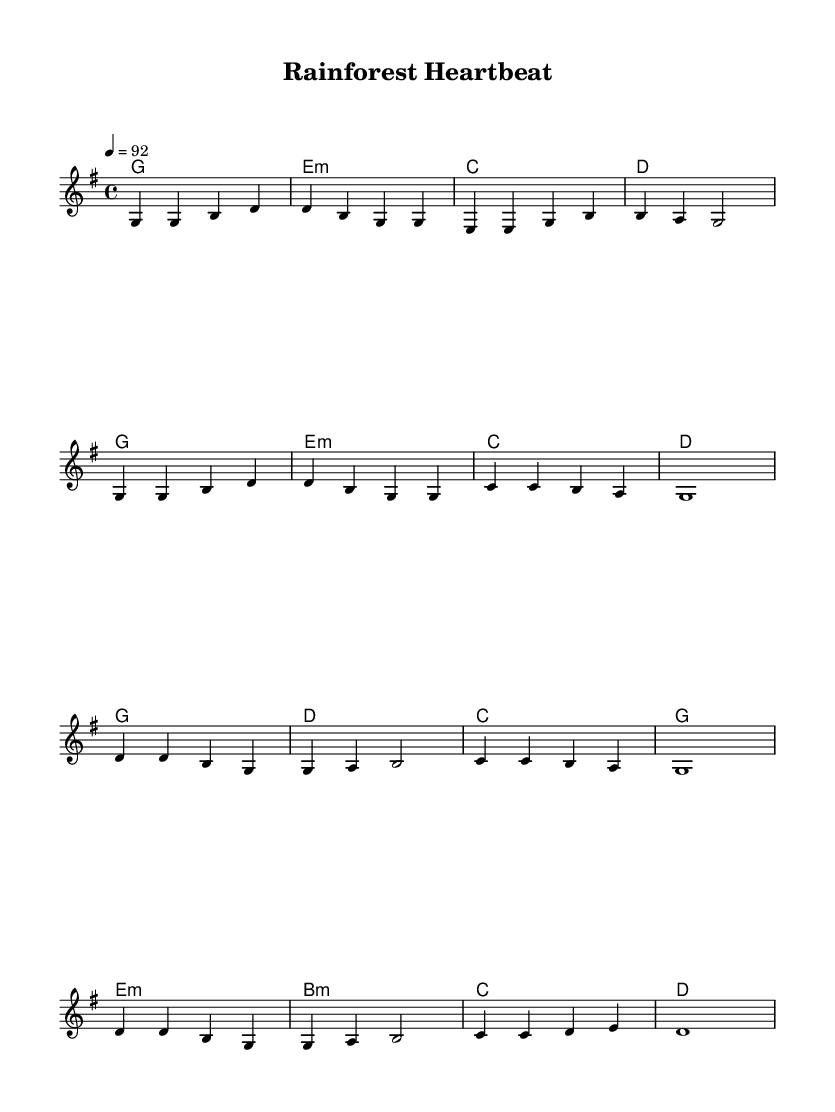What is the key signature of this music? The key signature is G major, which has one sharp (F#).
Answer: G major What is the time signature of this music? The time signature is 4/4, indicating four beats per measure.
Answer: 4/4 What is the tempo marking for this piece? The tempo marking is quarter note equals 92, indicating the speed of the music.
Answer: 92 How many measures are there in the verse? The verse consists of 8 measures, each represented by a sequence of notes and chords.
Answer: 8 What is the chord progression used in the chorus? The chord progression in the chorus is G, D, C, G, E minor, B minor, C, D, which outlines the harmonic structure.
Answer: G, D, C, G, E minor, B minor, C, D How many different chord types are used throughout the song? The piece employs three chord types: major, minor, and diminished, indicating the diversity in harmony.
Answer: 3 chord types Which section of the song is repeated after the verse? The chorus follows the verse, repeating the thematic material with the same melody and chord progression.
Answer: Chorus 